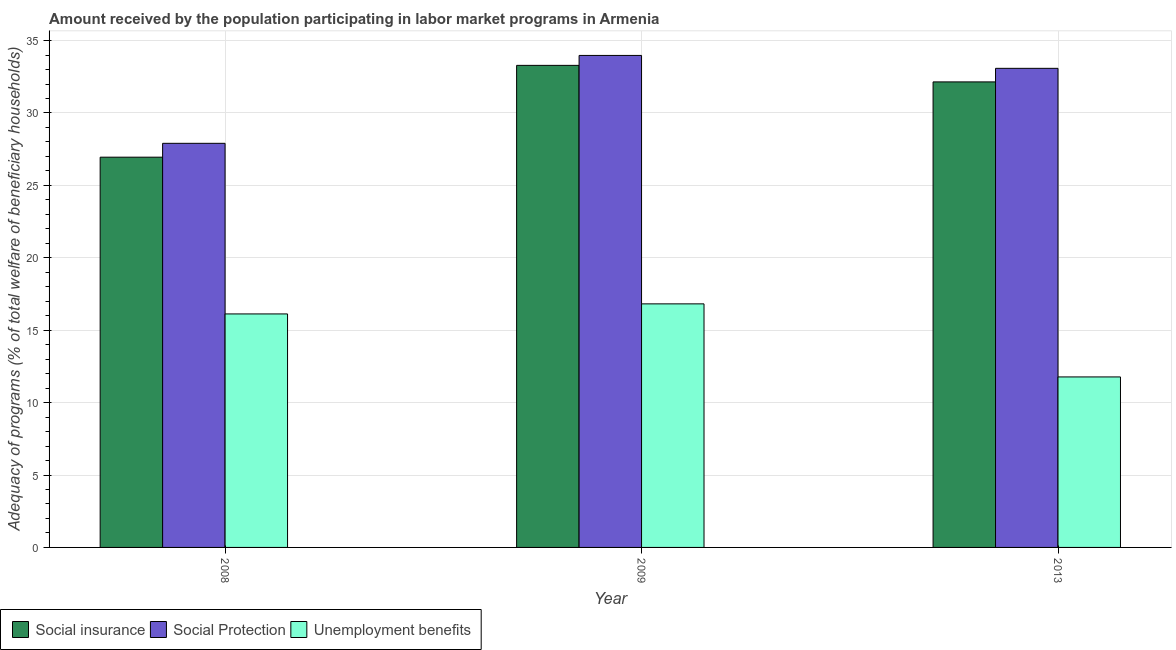How many different coloured bars are there?
Your answer should be compact. 3. How many groups of bars are there?
Provide a short and direct response. 3. In how many cases, is the number of bars for a given year not equal to the number of legend labels?
Ensure brevity in your answer.  0. What is the amount received by the population participating in social protection programs in 2013?
Offer a terse response. 33.08. Across all years, what is the maximum amount received by the population participating in social protection programs?
Provide a short and direct response. 33.98. Across all years, what is the minimum amount received by the population participating in unemployment benefits programs?
Offer a terse response. 11.77. In which year was the amount received by the population participating in social protection programs maximum?
Your response must be concise. 2009. What is the total amount received by the population participating in unemployment benefits programs in the graph?
Give a very brief answer. 44.72. What is the difference between the amount received by the population participating in unemployment benefits programs in 2008 and that in 2009?
Ensure brevity in your answer.  -0.7. What is the difference between the amount received by the population participating in social insurance programs in 2013 and the amount received by the population participating in social protection programs in 2008?
Your response must be concise. 5.2. What is the average amount received by the population participating in unemployment benefits programs per year?
Offer a very short reply. 14.91. In the year 2013, what is the difference between the amount received by the population participating in social protection programs and amount received by the population participating in social insurance programs?
Keep it short and to the point. 0. In how many years, is the amount received by the population participating in social insurance programs greater than 28 %?
Provide a short and direct response. 2. What is the ratio of the amount received by the population participating in social insurance programs in 2008 to that in 2013?
Provide a short and direct response. 0.84. Is the difference between the amount received by the population participating in social protection programs in 2009 and 2013 greater than the difference between the amount received by the population participating in unemployment benefits programs in 2009 and 2013?
Your answer should be compact. No. What is the difference between the highest and the second highest amount received by the population participating in social protection programs?
Make the answer very short. 0.89. What is the difference between the highest and the lowest amount received by the population participating in unemployment benefits programs?
Your response must be concise. 5.05. Is the sum of the amount received by the population participating in unemployment benefits programs in 2008 and 2009 greater than the maximum amount received by the population participating in social insurance programs across all years?
Provide a short and direct response. Yes. What does the 2nd bar from the left in 2013 represents?
Make the answer very short. Social Protection. What does the 1st bar from the right in 2013 represents?
Your answer should be very brief. Unemployment benefits. How many bars are there?
Your answer should be very brief. 9. Are all the bars in the graph horizontal?
Keep it short and to the point. No. What is the title of the graph?
Make the answer very short. Amount received by the population participating in labor market programs in Armenia. What is the label or title of the X-axis?
Ensure brevity in your answer.  Year. What is the label or title of the Y-axis?
Give a very brief answer. Adequacy of programs (% of total welfare of beneficiary households). What is the Adequacy of programs (% of total welfare of beneficiary households) in Social insurance in 2008?
Provide a succinct answer. 26.95. What is the Adequacy of programs (% of total welfare of beneficiary households) in Social Protection in 2008?
Your answer should be compact. 27.91. What is the Adequacy of programs (% of total welfare of beneficiary households) in Unemployment benefits in 2008?
Keep it short and to the point. 16.12. What is the Adequacy of programs (% of total welfare of beneficiary households) in Social insurance in 2009?
Your answer should be very brief. 33.29. What is the Adequacy of programs (% of total welfare of beneficiary households) in Social Protection in 2009?
Keep it short and to the point. 33.98. What is the Adequacy of programs (% of total welfare of beneficiary households) of Unemployment benefits in 2009?
Ensure brevity in your answer.  16.82. What is the Adequacy of programs (% of total welfare of beneficiary households) in Social insurance in 2013?
Your response must be concise. 32.15. What is the Adequacy of programs (% of total welfare of beneficiary households) of Social Protection in 2013?
Offer a terse response. 33.08. What is the Adequacy of programs (% of total welfare of beneficiary households) in Unemployment benefits in 2013?
Provide a succinct answer. 11.77. Across all years, what is the maximum Adequacy of programs (% of total welfare of beneficiary households) of Social insurance?
Make the answer very short. 33.29. Across all years, what is the maximum Adequacy of programs (% of total welfare of beneficiary households) of Social Protection?
Ensure brevity in your answer.  33.98. Across all years, what is the maximum Adequacy of programs (% of total welfare of beneficiary households) in Unemployment benefits?
Ensure brevity in your answer.  16.82. Across all years, what is the minimum Adequacy of programs (% of total welfare of beneficiary households) of Social insurance?
Offer a terse response. 26.95. Across all years, what is the minimum Adequacy of programs (% of total welfare of beneficiary households) of Social Protection?
Offer a very short reply. 27.91. Across all years, what is the minimum Adequacy of programs (% of total welfare of beneficiary households) of Unemployment benefits?
Offer a terse response. 11.77. What is the total Adequacy of programs (% of total welfare of beneficiary households) of Social insurance in the graph?
Give a very brief answer. 92.39. What is the total Adequacy of programs (% of total welfare of beneficiary households) in Social Protection in the graph?
Give a very brief answer. 94.97. What is the total Adequacy of programs (% of total welfare of beneficiary households) of Unemployment benefits in the graph?
Your answer should be compact. 44.72. What is the difference between the Adequacy of programs (% of total welfare of beneficiary households) in Social insurance in 2008 and that in 2009?
Provide a short and direct response. -6.34. What is the difference between the Adequacy of programs (% of total welfare of beneficiary households) of Social Protection in 2008 and that in 2009?
Ensure brevity in your answer.  -6.07. What is the difference between the Adequacy of programs (% of total welfare of beneficiary households) in Unemployment benefits in 2008 and that in 2009?
Keep it short and to the point. -0.7. What is the difference between the Adequacy of programs (% of total welfare of beneficiary households) in Social insurance in 2008 and that in 2013?
Your response must be concise. -5.2. What is the difference between the Adequacy of programs (% of total welfare of beneficiary households) in Social Protection in 2008 and that in 2013?
Your answer should be compact. -5.18. What is the difference between the Adequacy of programs (% of total welfare of beneficiary households) in Unemployment benefits in 2008 and that in 2013?
Ensure brevity in your answer.  4.35. What is the difference between the Adequacy of programs (% of total welfare of beneficiary households) in Social insurance in 2009 and that in 2013?
Keep it short and to the point. 1.14. What is the difference between the Adequacy of programs (% of total welfare of beneficiary households) of Social Protection in 2009 and that in 2013?
Your answer should be very brief. 0.89. What is the difference between the Adequacy of programs (% of total welfare of beneficiary households) in Unemployment benefits in 2009 and that in 2013?
Your answer should be very brief. 5.05. What is the difference between the Adequacy of programs (% of total welfare of beneficiary households) in Social insurance in 2008 and the Adequacy of programs (% of total welfare of beneficiary households) in Social Protection in 2009?
Your answer should be very brief. -7.03. What is the difference between the Adequacy of programs (% of total welfare of beneficiary households) in Social insurance in 2008 and the Adequacy of programs (% of total welfare of beneficiary households) in Unemployment benefits in 2009?
Your answer should be compact. 10.13. What is the difference between the Adequacy of programs (% of total welfare of beneficiary households) in Social Protection in 2008 and the Adequacy of programs (% of total welfare of beneficiary households) in Unemployment benefits in 2009?
Your answer should be very brief. 11.09. What is the difference between the Adequacy of programs (% of total welfare of beneficiary households) in Social insurance in 2008 and the Adequacy of programs (% of total welfare of beneficiary households) in Social Protection in 2013?
Offer a very short reply. -6.14. What is the difference between the Adequacy of programs (% of total welfare of beneficiary households) of Social insurance in 2008 and the Adequacy of programs (% of total welfare of beneficiary households) of Unemployment benefits in 2013?
Offer a very short reply. 15.17. What is the difference between the Adequacy of programs (% of total welfare of beneficiary households) in Social Protection in 2008 and the Adequacy of programs (% of total welfare of beneficiary households) in Unemployment benefits in 2013?
Offer a very short reply. 16.13. What is the difference between the Adequacy of programs (% of total welfare of beneficiary households) of Social insurance in 2009 and the Adequacy of programs (% of total welfare of beneficiary households) of Social Protection in 2013?
Your response must be concise. 0.21. What is the difference between the Adequacy of programs (% of total welfare of beneficiary households) in Social insurance in 2009 and the Adequacy of programs (% of total welfare of beneficiary households) in Unemployment benefits in 2013?
Your response must be concise. 21.52. What is the difference between the Adequacy of programs (% of total welfare of beneficiary households) in Social Protection in 2009 and the Adequacy of programs (% of total welfare of beneficiary households) in Unemployment benefits in 2013?
Provide a short and direct response. 22.2. What is the average Adequacy of programs (% of total welfare of beneficiary households) of Social insurance per year?
Make the answer very short. 30.8. What is the average Adequacy of programs (% of total welfare of beneficiary households) of Social Protection per year?
Your answer should be very brief. 31.66. What is the average Adequacy of programs (% of total welfare of beneficiary households) of Unemployment benefits per year?
Ensure brevity in your answer.  14.91. In the year 2008, what is the difference between the Adequacy of programs (% of total welfare of beneficiary households) of Social insurance and Adequacy of programs (% of total welfare of beneficiary households) of Social Protection?
Give a very brief answer. -0.96. In the year 2008, what is the difference between the Adequacy of programs (% of total welfare of beneficiary households) in Social insurance and Adequacy of programs (% of total welfare of beneficiary households) in Unemployment benefits?
Provide a short and direct response. 10.82. In the year 2008, what is the difference between the Adequacy of programs (% of total welfare of beneficiary households) of Social Protection and Adequacy of programs (% of total welfare of beneficiary households) of Unemployment benefits?
Provide a short and direct response. 11.78. In the year 2009, what is the difference between the Adequacy of programs (% of total welfare of beneficiary households) in Social insurance and Adequacy of programs (% of total welfare of beneficiary households) in Social Protection?
Give a very brief answer. -0.69. In the year 2009, what is the difference between the Adequacy of programs (% of total welfare of beneficiary households) of Social insurance and Adequacy of programs (% of total welfare of beneficiary households) of Unemployment benefits?
Keep it short and to the point. 16.47. In the year 2009, what is the difference between the Adequacy of programs (% of total welfare of beneficiary households) in Social Protection and Adequacy of programs (% of total welfare of beneficiary households) in Unemployment benefits?
Provide a short and direct response. 17.16. In the year 2013, what is the difference between the Adequacy of programs (% of total welfare of beneficiary households) of Social insurance and Adequacy of programs (% of total welfare of beneficiary households) of Social Protection?
Provide a short and direct response. -0.94. In the year 2013, what is the difference between the Adequacy of programs (% of total welfare of beneficiary households) in Social insurance and Adequacy of programs (% of total welfare of beneficiary households) in Unemployment benefits?
Give a very brief answer. 20.37. In the year 2013, what is the difference between the Adequacy of programs (% of total welfare of beneficiary households) of Social Protection and Adequacy of programs (% of total welfare of beneficiary households) of Unemployment benefits?
Offer a very short reply. 21.31. What is the ratio of the Adequacy of programs (% of total welfare of beneficiary households) of Social insurance in 2008 to that in 2009?
Your response must be concise. 0.81. What is the ratio of the Adequacy of programs (% of total welfare of beneficiary households) in Social Protection in 2008 to that in 2009?
Keep it short and to the point. 0.82. What is the ratio of the Adequacy of programs (% of total welfare of beneficiary households) of Unemployment benefits in 2008 to that in 2009?
Offer a very short reply. 0.96. What is the ratio of the Adequacy of programs (% of total welfare of beneficiary households) of Social insurance in 2008 to that in 2013?
Your answer should be very brief. 0.84. What is the ratio of the Adequacy of programs (% of total welfare of beneficiary households) of Social Protection in 2008 to that in 2013?
Offer a very short reply. 0.84. What is the ratio of the Adequacy of programs (% of total welfare of beneficiary households) of Unemployment benefits in 2008 to that in 2013?
Keep it short and to the point. 1.37. What is the ratio of the Adequacy of programs (% of total welfare of beneficiary households) in Social insurance in 2009 to that in 2013?
Your response must be concise. 1.04. What is the ratio of the Adequacy of programs (% of total welfare of beneficiary households) of Unemployment benefits in 2009 to that in 2013?
Ensure brevity in your answer.  1.43. What is the difference between the highest and the second highest Adequacy of programs (% of total welfare of beneficiary households) of Social insurance?
Ensure brevity in your answer.  1.14. What is the difference between the highest and the second highest Adequacy of programs (% of total welfare of beneficiary households) in Social Protection?
Keep it short and to the point. 0.89. What is the difference between the highest and the second highest Adequacy of programs (% of total welfare of beneficiary households) of Unemployment benefits?
Ensure brevity in your answer.  0.7. What is the difference between the highest and the lowest Adequacy of programs (% of total welfare of beneficiary households) of Social insurance?
Offer a terse response. 6.34. What is the difference between the highest and the lowest Adequacy of programs (% of total welfare of beneficiary households) of Social Protection?
Ensure brevity in your answer.  6.07. What is the difference between the highest and the lowest Adequacy of programs (% of total welfare of beneficiary households) in Unemployment benefits?
Provide a short and direct response. 5.05. 